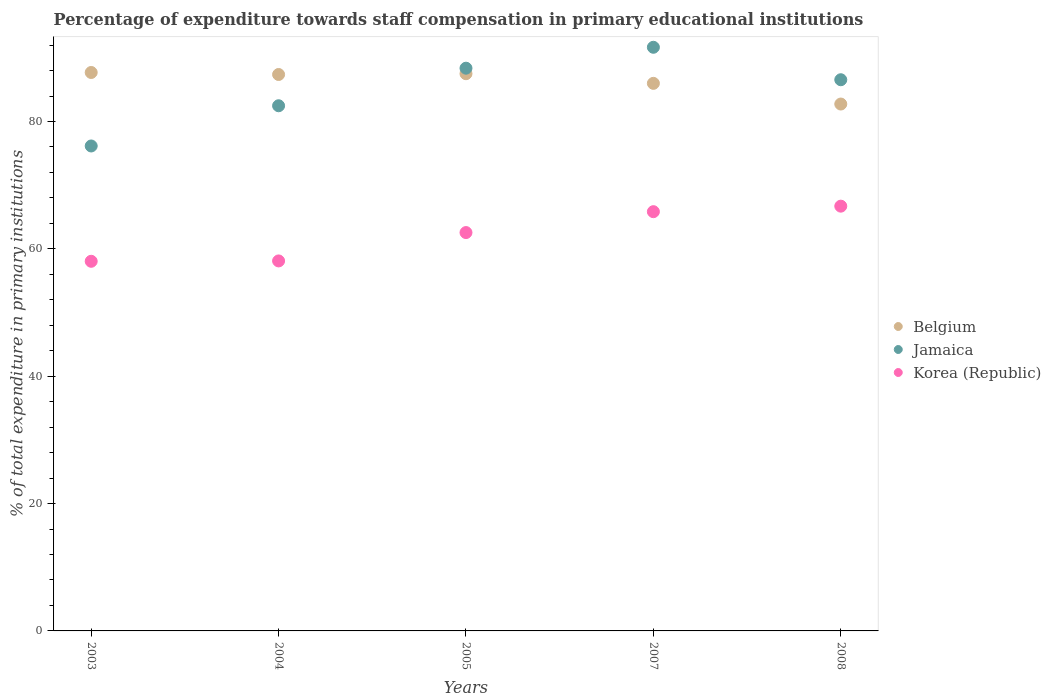How many different coloured dotlines are there?
Give a very brief answer. 3. What is the percentage of expenditure towards staff compensation in Jamaica in 2007?
Keep it short and to the point. 91.66. Across all years, what is the maximum percentage of expenditure towards staff compensation in Korea (Republic)?
Keep it short and to the point. 66.71. Across all years, what is the minimum percentage of expenditure towards staff compensation in Korea (Republic)?
Give a very brief answer. 58.05. In which year was the percentage of expenditure towards staff compensation in Korea (Republic) minimum?
Your response must be concise. 2003. What is the total percentage of expenditure towards staff compensation in Belgium in the graph?
Your answer should be compact. 431.33. What is the difference between the percentage of expenditure towards staff compensation in Korea (Republic) in 2005 and that in 2008?
Your response must be concise. -4.15. What is the difference between the percentage of expenditure towards staff compensation in Belgium in 2008 and the percentage of expenditure towards staff compensation in Korea (Republic) in 2007?
Keep it short and to the point. 16.9. What is the average percentage of expenditure towards staff compensation in Jamaica per year?
Offer a very short reply. 85.04. In the year 2004, what is the difference between the percentage of expenditure towards staff compensation in Belgium and percentage of expenditure towards staff compensation in Korea (Republic)?
Provide a short and direct response. 29.28. What is the ratio of the percentage of expenditure towards staff compensation in Belgium in 2007 to that in 2008?
Offer a terse response. 1.04. Is the difference between the percentage of expenditure towards staff compensation in Belgium in 2007 and 2008 greater than the difference between the percentage of expenditure towards staff compensation in Korea (Republic) in 2007 and 2008?
Your answer should be very brief. Yes. What is the difference between the highest and the second highest percentage of expenditure towards staff compensation in Korea (Republic)?
Your answer should be very brief. 0.87. What is the difference between the highest and the lowest percentage of expenditure towards staff compensation in Korea (Republic)?
Your answer should be compact. 8.66. In how many years, is the percentage of expenditure towards staff compensation in Korea (Republic) greater than the average percentage of expenditure towards staff compensation in Korea (Republic) taken over all years?
Offer a very short reply. 3. Is the sum of the percentage of expenditure towards staff compensation in Belgium in 2005 and 2008 greater than the maximum percentage of expenditure towards staff compensation in Korea (Republic) across all years?
Offer a very short reply. Yes. Is it the case that in every year, the sum of the percentage of expenditure towards staff compensation in Jamaica and percentage of expenditure towards staff compensation in Belgium  is greater than the percentage of expenditure towards staff compensation in Korea (Republic)?
Keep it short and to the point. Yes. Does the percentage of expenditure towards staff compensation in Jamaica monotonically increase over the years?
Provide a short and direct response. No. Is the percentage of expenditure towards staff compensation in Jamaica strictly greater than the percentage of expenditure towards staff compensation in Belgium over the years?
Ensure brevity in your answer.  No. Is the percentage of expenditure towards staff compensation in Belgium strictly less than the percentage of expenditure towards staff compensation in Korea (Republic) over the years?
Your answer should be very brief. No. How many dotlines are there?
Your answer should be compact. 3. How many years are there in the graph?
Provide a succinct answer. 5. What is the difference between two consecutive major ticks on the Y-axis?
Keep it short and to the point. 20. Are the values on the major ticks of Y-axis written in scientific E-notation?
Offer a terse response. No. Does the graph contain grids?
Provide a succinct answer. No. Where does the legend appear in the graph?
Provide a succinct answer. Center right. How are the legend labels stacked?
Your answer should be compact. Vertical. What is the title of the graph?
Keep it short and to the point. Percentage of expenditure towards staff compensation in primary educational institutions. Does "Bahrain" appear as one of the legend labels in the graph?
Your answer should be compact. No. What is the label or title of the X-axis?
Offer a terse response. Years. What is the label or title of the Y-axis?
Give a very brief answer. % of total expenditure in primary institutions. What is the % of total expenditure in primary institutions in Belgium in 2003?
Your answer should be compact. 87.7. What is the % of total expenditure in primary institutions of Jamaica in 2003?
Keep it short and to the point. 76.16. What is the % of total expenditure in primary institutions in Korea (Republic) in 2003?
Your answer should be very brief. 58.05. What is the % of total expenditure in primary institutions of Belgium in 2004?
Your answer should be compact. 87.38. What is the % of total expenditure in primary institutions in Jamaica in 2004?
Your answer should be very brief. 82.47. What is the % of total expenditure in primary institutions in Korea (Republic) in 2004?
Offer a terse response. 58.11. What is the % of total expenditure in primary institutions in Belgium in 2005?
Your answer should be compact. 87.51. What is the % of total expenditure in primary institutions in Jamaica in 2005?
Your answer should be compact. 88.37. What is the % of total expenditure in primary institutions in Korea (Republic) in 2005?
Give a very brief answer. 62.56. What is the % of total expenditure in primary institutions in Belgium in 2007?
Your answer should be very brief. 85.99. What is the % of total expenditure in primary institutions in Jamaica in 2007?
Your answer should be very brief. 91.66. What is the % of total expenditure in primary institutions in Korea (Republic) in 2007?
Offer a very short reply. 65.84. What is the % of total expenditure in primary institutions in Belgium in 2008?
Your answer should be very brief. 82.74. What is the % of total expenditure in primary institutions in Jamaica in 2008?
Your answer should be compact. 86.56. What is the % of total expenditure in primary institutions of Korea (Republic) in 2008?
Keep it short and to the point. 66.71. Across all years, what is the maximum % of total expenditure in primary institutions in Belgium?
Provide a succinct answer. 87.7. Across all years, what is the maximum % of total expenditure in primary institutions in Jamaica?
Offer a terse response. 91.66. Across all years, what is the maximum % of total expenditure in primary institutions in Korea (Republic)?
Ensure brevity in your answer.  66.71. Across all years, what is the minimum % of total expenditure in primary institutions in Belgium?
Keep it short and to the point. 82.74. Across all years, what is the minimum % of total expenditure in primary institutions in Jamaica?
Offer a very short reply. 76.16. Across all years, what is the minimum % of total expenditure in primary institutions of Korea (Republic)?
Your response must be concise. 58.05. What is the total % of total expenditure in primary institutions of Belgium in the graph?
Make the answer very short. 431.33. What is the total % of total expenditure in primary institutions of Jamaica in the graph?
Give a very brief answer. 425.22. What is the total % of total expenditure in primary institutions of Korea (Republic) in the graph?
Ensure brevity in your answer.  311.26. What is the difference between the % of total expenditure in primary institutions of Belgium in 2003 and that in 2004?
Provide a short and direct response. 0.32. What is the difference between the % of total expenditure in primary institutions of Jamaica in 2003 and that in 2004?
Make the answer very short. -6.32. What is the difference between the % of total expenditure in primary institutions in Korea (Republic) in 2003 and that in 2004?
Offer a terse response. -0.06. What is the difference between the % of total expenditure in primary institutions in Belgium in 2003 and that in 2005?
Make the answer very short. 0.19. What is the difference between the % of total expenditure in primary institutions of Jamaica in 2003 and that in 2005?
Offer a terse response. -12.22. What is the difference between the % of total expenditure in primary institutions in Korea (Republic) in 2003 and that in 2005?
Offer a terse response. -4.51. What is the difference between the % of total expenditure in primary institutions in Belgium in 2003 and that in 2007?
Offer a terse response. 1.71. What is the difference between the % of total expenditure in primary institutions of Jamaica in 2003 and that in 2007?
Provide a short and direct response. -15.5. What is the difference between the % of total expenditure in primary institutions of Korea (Republic) in 2003 and that in 2007?
Your answer should be compact. -7.79. What is the difference between the % of total expenditure in primary institutions in Belgium in 2003 and that in 2008?
Your answer should be very brief. 4.96. What is the difference between the % of total expenditure in primary institutions in Jamaica in 2003 and that in 2008?
Ensure brevity in your answer.  -10.4. What is the difference between the % of total expenditure in primary institutions in Korea (Republic) in 2003 and that in 2008?
Make the answer very short. -8.66. What is the difference between the % of total expenditure in primary institutions in Belgium in 2004 and that in 2005?
Make the answer very short. -0.12. What is the difference between the % of total expenditure in primary institutions of Jamaica in 2004 and that in 2005?
Your response must be concise. -5.9. What is the difference between the % of total expenditure in primary institutions of Korea (Republic) in 2004 and that in 2005?
Provide a short and direct response. -4.45. What is the difference between the % of total expenditure in primary institutions in Belgium in 2004 and that in 2007?
Your answer should be compact. 1.39. What is the difference between the % of total expenditure in primary institutions in Jamaica in 2004 and that in 2007?
Your answer should be very brief. -9.18. What is the difference between the % of total expenditure in primary institutions in Korea (Republic) in 2004 and that in 2007?
Offer a very short reply. -7.73. What is the difference between the % of total expenditure in primary institutions of Belgium in 2004 and that in 2008?
Your response must be concise. 4.64. What is the difference between the % of total expenditure in primary institutions in Jamaica in 2004 and that in 2008?
Ensure brevity in your answer.  -4.09. What is the difference between the % of total expenditure in primary institutions of Korea (Republic) in 2004 and that in 2008?
Offer a very short reply. -8.6. What is the difference between the % of total expenditure in primary institutions in Belgium in 2005 and that in 2007?
Make the answer very short. 1.51. What is the difference between the % of total expenditure in primary institutions in Jamaica in 2005 and that in 2007?
Offer a terse response. -3.28. What is the difference between the % of total expenditure in primary institutions of Korea (Republic) in 2005 and that in 2007?
Your response must be concise. -3.28. What is the difference between the % of total expenditure in primary institutions of Belgium in 2005 and that in 2008?
Your response must be concise. 4.76. What is the difference between the % of total expenditure in primary institutions in Jamaica in 2005 and that in 2008?
Give a very brief answer. 1.81. What is the difference between the % of total expenditure in primary institutions in Korea (Republic) in 2005 and that in 2008?
Give a very brief answer. -4.15. What is the difference between the % of total expenditure in primary institutions of Belgium in 2007 and that in 2008?
Provide a succinct answer. 3.25. What is the difference between the % of total expenditure in primary institutions of Jamaica in 2007 and that in 2008?
Your response must be concise. 5.1. What is the difference between the % of total expenditure in primary institutions of Korea (Republic) in 2007 and that in 2008?
Make the answer very short. -0.87. What is the difference between the % of total expenditure in primary institutions in Belgium in 2003 and the % of total expenditure in primary institutions in Jamaica in 2004?
Offer a very short reply. 5.23. What is the difference between the % of total expenditure in primary institutions in Belgium in 2003 and the % of total expenditure in primary institutions in Korea (Republic) in 2004?
Offer a very short reply. 29.59. What is the difference between the % of total expenditure in primary institutions of Jamaica in 2003 and the % of total expenditure in primary institutions of Korea (Republic) in 2004?
Offer a very short reply. 18.05. What is the difference between the % of total expenditure in primary institutions in Belgium in 2003 and the % of total expenditure in primary institutions in Jamaica in 2005?
Offer a terse response. -0.67. What is the difference between the % of total expenditure in primary institutions in Belgium in 2003 and the % of total expenditure in primary institutions in Korea (Republic) in 2005?
Your answer should be compact. 25.14. What is the difference between the % of total expenditure in primary institutions in Jamaica in 2003 and the % of total expenditure in primary institutions in Korea (Republic) in 2005?
Make the answer very short. 13.6. What is the difference between the % of total expenditure in primary institutions of Belgium in 2003 and the % of total expenditure in primary institutions of Jamaica in 2007?
Offer a very short reply. -3.96. What is the difference between the % of total expenditure in primary institutions in Belgium in 2003 and the % of total expenditure in primary institutions in Korea (Republic) in 2007?
Provide a succinct answer. 21.86. What is the difference between the % of total expenditure in primary institutions in Jamaica in 2003 and the % of total expenditure in primary institutions in Korea (Republic) in 2007?
Your answer should be compact. 10.32. What is the difference between the % of total expenditure in primary institutions of Belgium in 2003 and the % of total expenditure in primary institutions of Jamaica in 2008?
Your answer should be very brief. 1.14. What is the difference between the % of total expenditure in primary institutions of Belgium in 2003 and the % of total expenditure in primary institutions of Korea (Republic) in 2008?
Offer a very short reply. 20.99. What is the difference between the % of total expenditure in primary institutions in Jamaica in 2003 and the % of total expenditure in primary institutions in Korea (Republic) in 2008?
Provide a succinct answer. 9.45. What is the difference between the % of total expenditure in primary institutions in Belgium in 2004 and the % of total expenditure in primary institutions in Jamaica in 2005?
Make the answer very short. -0.99. What is the difference between the % of total expenditure in primary institutions of Belgium in 2004 and the % of total expenditure in primary institutions of Korea (Republic) in 2005?
Ensure brevity in your answer.  24.82. What is the difference between the % of total expenditure in primary institutions in Jamaica in 2004 and the % of total expenditure in primary institutions in Korea (Republic) in 2005?
Your answer should be compact. 19.91. What is the difference between the % of total expenditure in primary institutions of Belgium in 2004 and the % of total expenditure in primary institutions of Jamaica in 2007?
Give a very brief answer. -4.27. What is the difference between the % of total expenditure in primary institutions in Belgium in 2004 and the % of total expenditure in primary institutions in Korea (Republic) in 2007?
Ensure brevity in your answer.  21.54. What is the difference between the % of total expenditure in primary institutions in Jamaica in 2004 and the % of total expenditure in primary institutions in Korea (Republic) in 2007?
Offer a terse response. 16.63. What is the difference between the % of total expenditure in primary institutions in Belgium in 2004 and the % of total expenditure in primary institutions in Jamaica in 2008?
Your answer should be very brief. 0.82. What is the difference between the % of total expenditure in primary institutions of Belgium in 2004 and the % of total expenditure in primary institutions of Korea (Republic) in 2008?
Your response must be concise. 20.68. What is the difference between the % of total expenditure in primary institutions in Jamaica in 2004 and the % of total expenditure in primary institutions in Korea (Republic) in 2008?
Provide a succinct answer. 15.77. What is the difference between the % of total expenditure in primary institutions in Belgium in 2005 and the % of total expenditure in primary institutions in Jamaica in 2007?
Your answer should be very brief. -4.15. What is the difference between the % of total expenditure in primary institutions in Belgium in 2005 and the % of total expenditure in primary institutions in Korea (Republic) in 2007?
Offer a very short reply. 21.67. What is the difference between the % of total expenditure in primary institutions of Jamaica in 2005 and the % of total expenditure in primary institutions of Korea (Republic) in 2007?
Offer a very short reply. 22.53. What is the difference between the % of total expenditure in primary institutions of Belgium in 2005 and the % of total expenditure in primary institutions of Jamaica in 2008?
Make the answer very short. 0.95. What is the difference between the % of total expenditure in primary institutions of Belgium in 2005 and the % of total expenditure in primary institutions of Korea (Republic) in 2008?
Make the answer very short. 20.8. What is the difference between the % of total expenditure in primary institutions of Jamaica in 2005 and the % of total expenditure in primary institutions of Korea (Republic) in 2008?
Provide a short and direct response. 21.67. What is the difference between the % of total expenditure in primary institutions of Belgium in 2007 and the % of total expenditure in primary institutions of Jamaica in 2008?
Your response must be concise. -0.57. What is the difference between the % of total expenditure in primary institutions of Belgium in 2007 and the % of total expenditure in primary institutions of Korea (Republic) in 2008?
Make the answer very short. 19.29. What is the difference between the % of total expenditure in primary institutions of Jamaica in 2007 and the % of total expenditure in primary institutions of Korea (Republic) in 2008?
Keep it short and to the point. 24.95. What is the average % of total expenditure in primary institutions of Belgium per year?
Give a very brief answer. 86.27. What is the average % of total expenditure in primary institutions of Jamaica per year?
Your answer should be compact. 85.04. What is the average % of total expenditure in primary institutions in Korea (Republic) per year?
Your answer should be compact. 62.25. In the year 2003, what is the difference between the % of total expenditure in primary institutions in Belgium and % of total expenditure in primary institutions in Jamaica?
Your answer should be very brief. 11.54. In the year 2003, what is the difference between the % of total expenditure in primary institutions in Belgium and % of total expenditure in primary institutions in Korea (Republic)?
Your answer should be very brief. 29.65. In the year 2003, what is the difference between the % of total expenditure in primary institutions of Jamaica and % of total expenditure in primary institutions of Korea (Republic)?
Ensure brevity in your answer.  18.11. In the year 2004, what is the difference between the % of total expenditure in primary institutions in Belgium and % of total expenditure in primary institutions in Jamaica?
Offer a terse response. 4.91. In the year 2004, what is the difference between the % of total expenditure in primary institutions in Belgium and % of total expenditure in primary institutions in Korea (Republic)?
Ensure brevity in your answer.  29.28. In the year 2004, what is the difference between the % of total expenditure in primary institutions of Jamaica and % of total expenditure in primary institutions of Korea (Republic)?
Give a very brief answer. 24.37. In the year 2005, what is the difference between the % of total expenditure in primary institutions of Belgium and % of total expenditure in primary institutions of Jamaica?
Provide a succinct answer. -0.87. In the year 2005, what is the difference between the % of total expenditure in primary institutions of Belgium and % of total expenditure in primary institutions of Korea (Republic)?
Provide a succinct answer. 24.95. In the year 2005, what is the difference between the % of total expenditure in primary institutions in Jamaica and % of total expenditure in primary institutions in Korea (Republic)?
Your response must be concise. 25.81. In the year 2007, what is the difference between the % of total expenditure in primary institutions in Belgium and % of total expenditure in primary institutions in Jamaica?
Your answer should be very brief. -5.67. In the year 2007, what is the difference between the % of total expenditure in primary institutions in Belgium and % of total expenditure in primary institutions in Korea (Republic)?
Your answer should be very brief. 20.15. In the year 2007, what is the difference between the % of total expenditure in primary institutions of Jamaica and % of total expenditure in primary institutions of Korea (Republic)?
Make the answer very short. 25.82. In the year 2008, what is the difference between the % of total expenditure in primary institutions of Belgium and % of total expenditure in primary institutions of Jamaica?
Your answer should be very brief. -3.82. In the year 2008, what is the difference between the % of total expenditure in primary institutions in Belgium and % of total expenditure in primary institutions in Korea (Republic)?
Offer a terse response. 16.04. In the year 2008, what is the difference between the % of total expenditure in primary institutions of Jamaica and % of total expenditure in primary institutions of Korea (Republic)?
Give a very brief answer. 19.85. What is the ratio of the % of total expenditure in primary institutions of Belgium in 2003 to that in 2004?
Offer a very short reply. 1. What is the ratio of the % of total expenditure in primary institutions in Jamaica in 2003 to that in 2004?
Your answer should be compact. 0.92. What is the ratio of the % of total expenditure in primary institutions in Jamaica in 2003 to that in 2005?
Your response must be concise. 0.86. What is the ratio of the % of total expenditure in primary institutions in Korea (Republic) in 2003 to that in 2005?
Offer a very short reply. 0.93. What is the ratio of the % of total expenditure in primary institutions of Belgium in 2003 to that in 2007?
Your answer should be compact. 1.02. What is the ratio of the % of total expenditure in primary institutions of Jamaica in 2003 to that in 2007?
Provide a short and direct response. 0.83. What is the ratio of the % of total expenditure in primary institutions in Korea (Republic) in 2003 to that in 2007?
Give a very brief answer. 0.88. What is the ratio of the % of total expenditure in primary institutions in Belgium in 2003 to that in 2008?
Make the answer very short. 1.06. What is the ratio of the % of total expenditure in primary institutions in Jamaica in 2003 to that in 2008?
Your response must be concise. 0.88. What is the ratio of the % of total expenditure in primary institutions of Korea (Republic) in 2003 to that in 2008?
Provide a succinct answer. 0.87. What is the ratio of the % of total expenditure in primary institutions in Jamaica in 2004 to that in 2005?
Offer a terse response. 0.93. What is the ratio of the % of total expenditure in primary institutions of Korea (Republic) in 2004 to that in 2005?
Your answer should be very brief. 0.93. What is the ratio of the % of total expenditure in primary institutions in Belgium in 2004 to that in 2007?
Offer a very short reply. 1.02. What is the ratio of the % of total expenditure in primary institutions of Jamaica in 2004 to that in 2007?
Your response must be concise. 0.9. What is the ratio of the % of total expenditure in primary institutions in Korea (Republic) in 2004 to that in 2007?
Provide a short and direct response. 0.88. What is the ratio of the % of total expenditure in primary institutions in Belgium in 2004 to that in 2008?
Offer a terse response. 1.06. What is the ratio of the % of total expenditure in primary institutions of Jamaica in 2004 to that in 2008?
Make the answer very short. 0.95. What is the ratio of the % of total expenditure in primary institutions in Korea (Republic) in 2004 to that in 2008?
Your answer should be very brief. 0.87. What is the ratio of the % of total expenditure in primary institutions of Belgium in 2005 to that in 2007?
Give a very brief answer. 1.02. What is the ratio of the % of total expenditure in primary institutions of Jamaica in 2005 to that in 2007?
Your answer should be very brief. 0.96. What is the ratio of the % of total expenditure in primary institutions of Korea (Republic) in 2005 to that in 2007?
Provide a short and direct response. 0.95. What is the ratio of the % of total expenditure in primary institutions of Belgium in 2005 to that in 2008?
Your answer should be very brief. 1.06. What is the ratio of the % of total expenditure in primary institutions of Korea (Republic) in 2005 to that in 2008?
Ensure brevity in your answer.  0.94. What is the ratio of the % of total expenditure in primary institutions of Belgium in 2007 to that in 2008?
Your response must be concise. 1.04. What is the ratio of the % of total expenditure in primary institutions of Jamaica in 2007 to that in 2008?
Give a very brief answer. 1.06. What is the ratio of the % of total expenditure in primary institutions of Korea (Republic) in 2007 to that in 2008?
Offer a terse response. 0.99. What is the difference between the highest and the second highest % of total expenditure in primary institutions of Belgium?
Ensure brevity in your answer.  0.19. What is the difference between the highest and the second highest % of total expenditure in primary institutions in Jamaica?
Provide a succinct answer. 3.28. What is the difference between the highest and the second highest % of total expenditure in primary institutions in Korea (Republic)?
Give a very brief answer. 0.87. What is the difference between the highest and the lowest % of total expenditure in primary institutions in Belgium?
Ensure brevity in your answer.  4.96. What is the difference between the highest and the lowest % of total expenditure in primary institutions in Jamaica?
Your answer should be compact. 15.5. What is the difference between the highest and the lowest % of total expenditure in primary institutions of Korea (Republic)?
Your answer should be very brief. 8.66. 